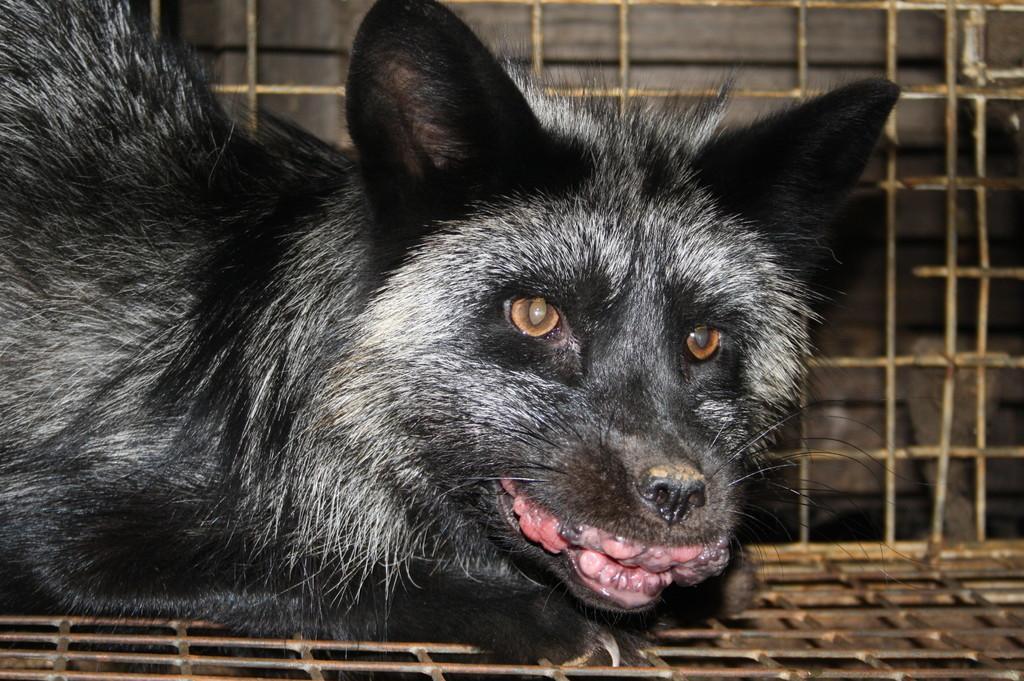In one or two sentences, can you explain what this image depicts? This image consists of a animal in black color. It is in a cage made up of metal. 